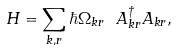<formula> <loc_0><loc_0><loc_500><loc_500>H = \sum _ { { k } , r } \hbar { \Omega } _ { { k } r } \ A _ { { k } r } ^ { \dagger } A _ { { k } r } ,</formula> 